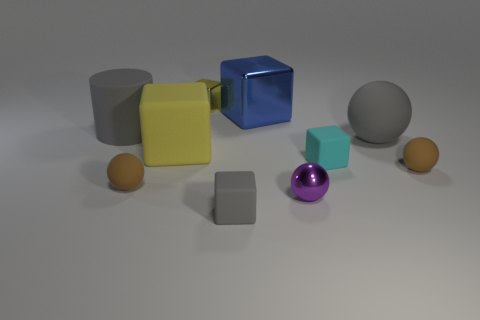What is the size of the rubber cylinder that is the same color as the large sphere? The rubber cylinder has a medium size, comparable to the smaller gray cube, and is the same vibrant purple color as the large sphere in the image. 